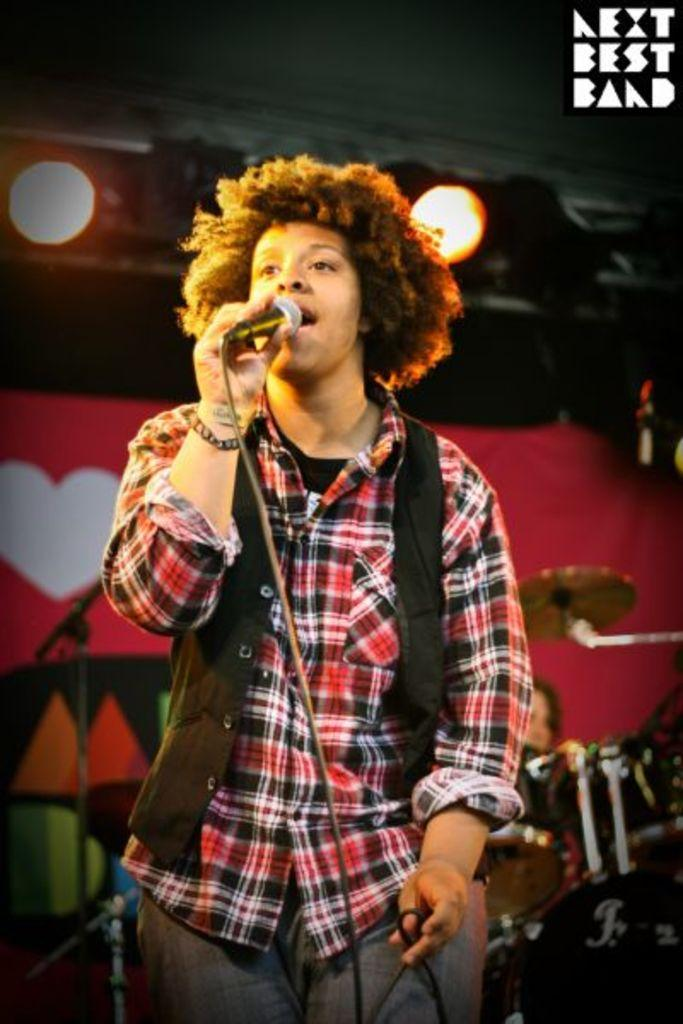What is the person in the foreground of the image holding? The person is holding a microphone in the image. What can be seen in the background of the image? There are musical instruments and another person visible in the background of the image. What else can be seen in the background of the image? There are lights and some objects visible in the background of the image. What type of wheel is visible in the image? There is no wheel present in the image. What can be said about the teeth of the person holding the microphone in the image? There is no information about the person's teeth in the image. 